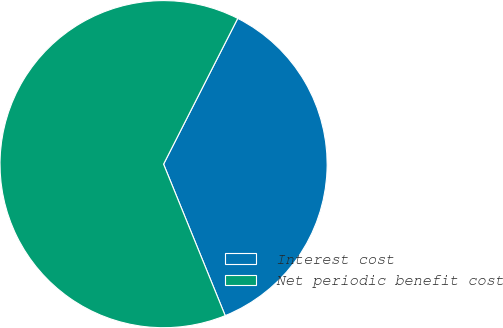Convert chart. <chart><loc_0><loc_0><loc_500><loc_500><pie_chart><fcel>Interest cost<fcel>Net periodic benefit cost<nl><fcel>36.36%<fcel>63.64%<nl></chart> 